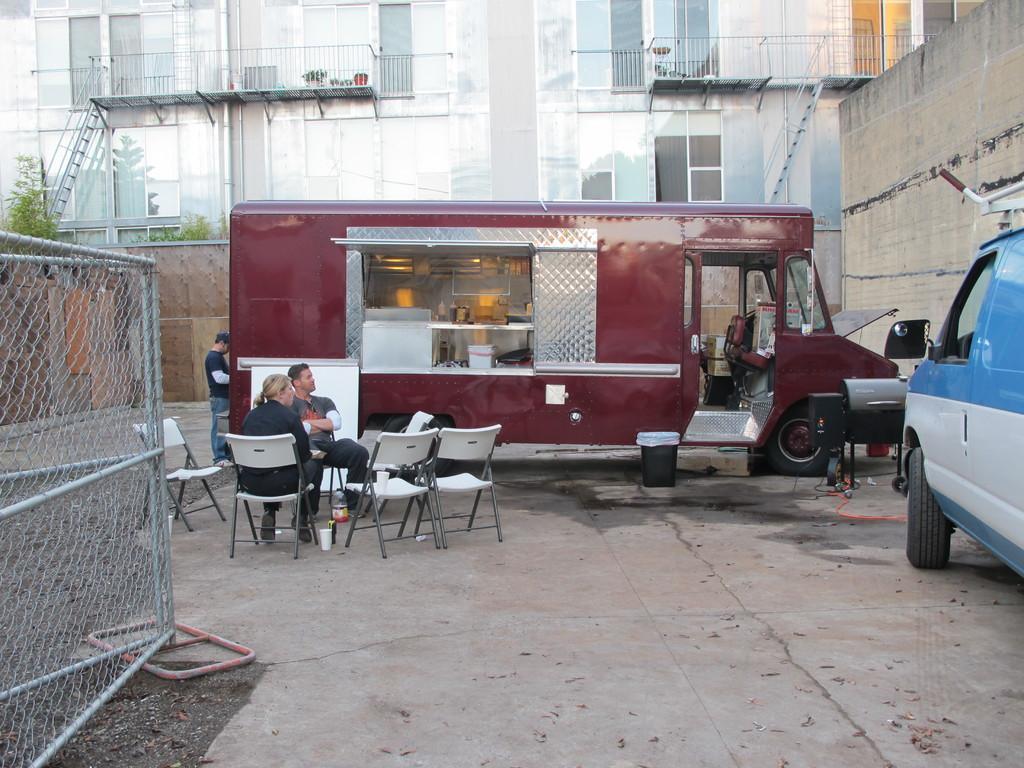Can you describe this image briefly? In this image, we can see few people , few are sat on the chairs. And there is a vehicles in the middle and right side. Here there is a dustbin. On left side, we can see fencing. Background, few building, glass window, fencing, ladder, some trees and walls we can see. 